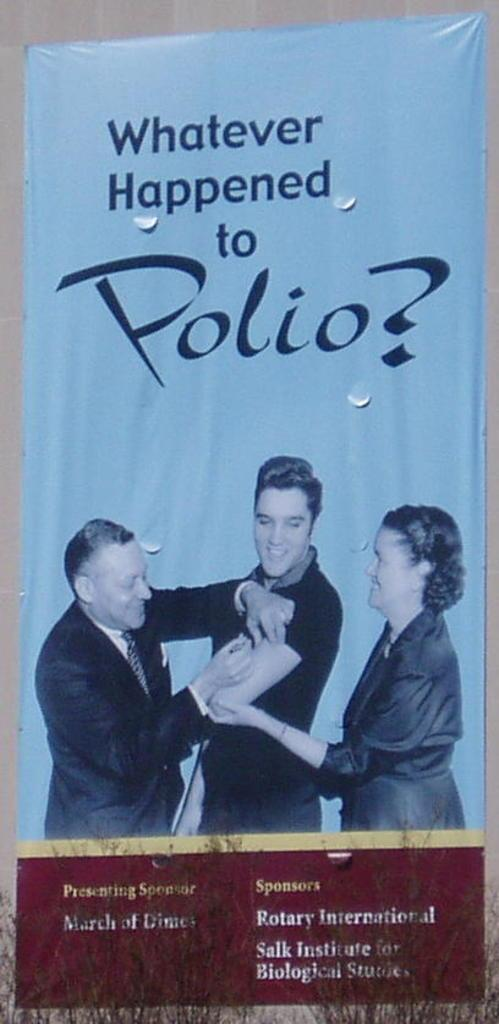<image>
Present a compact description of the photo's key features. Elvis Presley promoted Polio vaccination for presenting sponsor March of Dimes. 